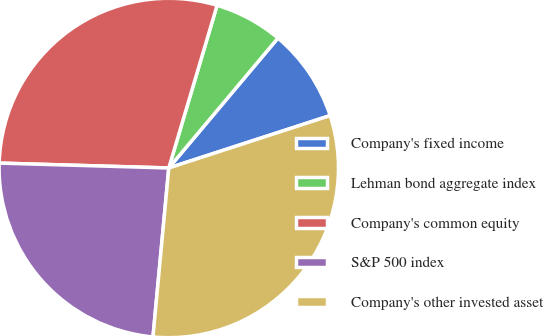<chart> <loc_0><loc_0><loc_500><loc_500><pie_chart><fcel>Company's fixed income<fcel>Lehman bond aggregate index<fcel>Company's common equity<fcel>S&P 500 index<fcel>Company's other invested asset<nl><fcel>8.88%<fcel>6.53%<fcel>29.14%<fcel>23.98%<fcel>31.49%<nl></chart> 